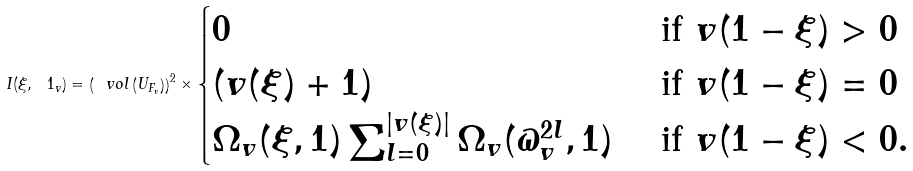Convert formula to latex. <formula><loc_0><loc_0><loc_500><loc_500>I ( \xi , \ 1 _ { v } ) = \left ( \ v o l \left ( U _ { F _ { v } } \right ) \right ) ^ { 2 } \times \begin{cases} 0 & \text { if } v ( 1 - \xi ) > 0 \\ ( v ( \xi ) + 1 ) & \text { if } v ( 1 - \xi ) = 0 \\ \Omega _ { v } ( \xi , 1 ) \sum _ { l = 0 } ^ { | v ( \xi ) | } \Omega _ { v } ( \varpi _ { v } ^ { 2 l } , 1 ) & \text { if } v ( 1 - \xi ) < 0 . \end{cases}</formula> 